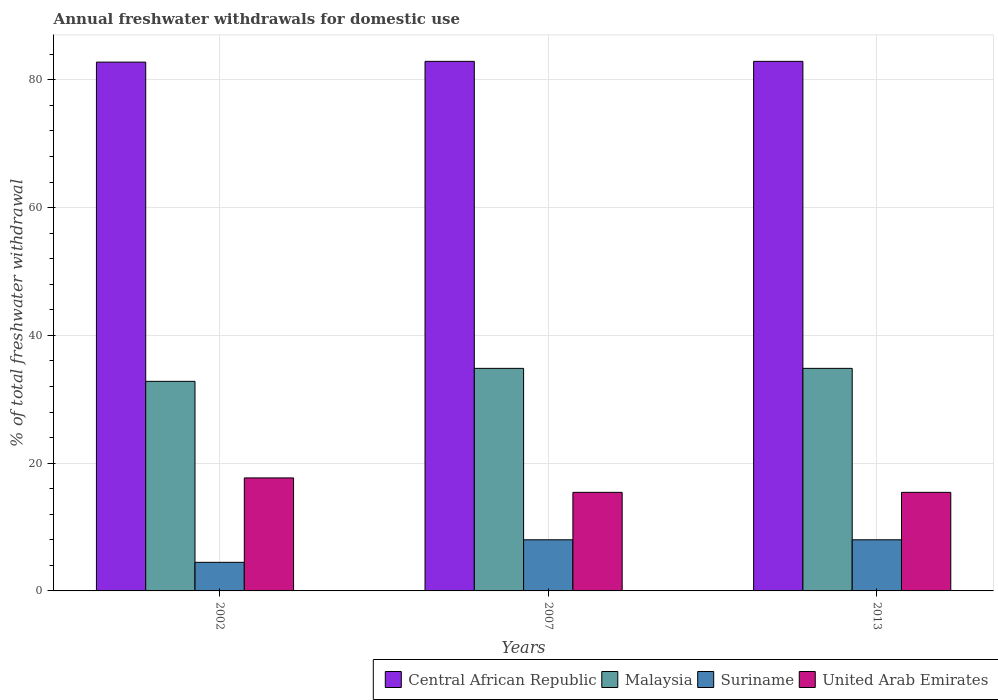How many different coloured bars are there?
Your answer should be compact. 4. In how many cases, is the number of bars for a given year not equal to the number of legend labels?
Your answer should be very brief. 0. What is the total annual withdrawals from freshwater in United Arab Emirates in 2007?
Make the answer very short. 15.43. Across all years, what is the maximum total annual withdrawals from freshwater in Malaysia?
Offer a terse response. 34.84. Across all years, what is the minimum total annual withdrawals from freshwater in United Arab Emirates?
Make the answer very short. 15.43. In which year was the total annual withdrawals from freshwater in United Arab Emirates minimum?
Ensure brevity in your answer.  2007. What is the total total annual withdrawals from freshwater in Central African Republic in the graph?
Give a very brief answer. 248.58. What is the difference between the total annual withdrawals from freshwater in United Arab Emirates in 2002 and that in 2013?
Provide a short and direct response. 2.26. What is the difference between the total annual withdrawals from freshwater in United Arab Emirates in 2002 and the total annual withdrawals from freshwater in Suriname in 2013?
Ensure brevity in your answer.  9.69. What is the average total annual withdrawals from freshwater in Suriname per year?
Your answer should be compact. 6.83. In the year 2002, what is the difference between the total annual withdrawals from freshwater in Suriname and total annual withdrawals from freshwater in Central African Republic?
Offer a very short reply. -78.3. What is the ratio of the total annual withdrawals from freshwater in United Arab Emirates in 2002 to that in 2007?
Make the answer very short. 1.15. Is the difference between the total annual withdrawals from freshwater in Suriname in 2007 and 2013 greater than the difference between the total annual withdrawals from freshwater in Central African Republic in 2007 and 2013?
Ensure brevity in your answer.  No. What is the difference between the highest and the second highest total annual withdrawals from freshwater in Central African Republic?
Give a very brief answer. 0. What is the difference between the highest and the lowest total annual withdrawals from freshwater in Central African Republic?
Your answer should be very brief. 0.12. Is the sum of the total annual withdrawals from freshwater in Central African Republic in 2002 and 2007 greater than the maximum total annual withdrawals from freshwater in Suriname across all years?
Provide a succinct answer. Yes. What does the 1st bar from the left in 2002 represents?
Provide a short and direct response. Central African Republic. What does the 4th bar from the right in 2007 represents?
Make the answer very short. Central African Republic. What is the difference between two consecutive major ticks on the Y-axis?
Keep it short and to the point. 20. Does the graph contain grids?
Offer a very short reply. Yes. How are the legend labels stacked?
Your answer should be compact. Horizontal. What is the title of the graph?
Keep it short and to the point. Annual freshwater withdrawals for domestic use. Does "United States" appear as one of the legend labels in the graph?
Ensure brevity in your answer.  No. What is the label or title of the Y-axis?
Make the answer very short. % of total freshwater withdrawal. What is the % of total freshwater withdrawal in Central African Republic in 2002?
Offer a terse response. 82.78. What is the % of total freshwater withdrawal in Malaysia in 2002?
Your answer should be compact. 32.81. What is the % of total freshwater withdrawal of Suriname in 2002?
Make the answer very short. 4.48. What is the % of total freshwater withdrawal in United Arab Emirates in 2002?
Provide a succinct answer. 17.69. What is the % of total freshwater withdrawal of Central African Republic in 2007?
Provide a short and direct response. 82.9. What is the % of total freshwater withdrawal in Malaysia in 2007?
Offer a terse response. 34.84. What is the % of total freshwater withdrawal in Suriname in 2007?
Keep it short and to the point. 8.01. What is the % of total freshwater withdrawal of United Arab Emirates in 2007?
Keep it short and to the point. 15.43. What is the % of total freshwater withdrawal in Central African Republic in 2013?
Your answer should be compact. 82.9. What is the % of total freshwater withdrawal of Malaysia in 2013?
Make the answer very short. 34.84. What is the % of total freshwater withdrawal in Suriname in 2013?
Provide a succinct answer. 8.01. What is the % of total freshwater withdrawal in United Arab Emirates in 2013?
Your answer should be very brief. 15.43. Across all years, what is the maximum % of total freshwater withdrawal of Central African Republic?
Give a very brief answer. 82.9. Across all years, what is the maximum % of total freshwater withdrawal of Malaysia?
Make the answer very short. 34.84. Across all years, what is the maximum % of total freshwater withdrawal in Suriname?
Your response must be concise. 8.01. Across all years, what is the maximum % of total freshwater withdrawal of United Arab Emirates?
Provide a short and direct response. 17.69. Across all years, what is the minimum % of total freshwater withdrawal of Central African Republic?
Keep it short and to the point. 82.78. Across all years, what is the minimum % of total freshwater withdrawal in Malaysia?
Offer a terse response. 32.81. Across all years, what is the minimum % of total freshwater withdrawal of Suriname?
Your answer should be compact. 4.48. Across all years, what is the minimum % of total freshwater withdrawal in United Arab Emirates?
Keep it short and to the point. 15.43. What is the total % of total freshwater withdrawal in Central African Republic in the graph?
Your answer should be compact. 248.58. What is the total % of total freshwater withdrawal of Malaysia in the graph?
Give a very brief answer. 102.49. What is the total % of total freshwater withdrawal in Suriname in the graph?
Your answer should be very brief. 20.49. What is the total % of total freshwater withdrawal in United Arab Emirates in the graph?
Make the answer very short. 48.55. What is the difference between the % of total freshwater withdrawal in Central African Republic in 2002 and that in 2007?
Offer a very short reply. -0.12. What is the difference between the % of total freshwater withdrawal in Malaysia in 2002 and that in 2007?
Offer a very short reply. -2.03. What is the difference between the % of total freshwater withdrawal in Suriname in 2002 and that in 2007?
Your answer should be very brief. -3.53. What is the difference between the % of total freshwater withdrawal of United Arab Emirates in 2002 and that in 2007?
Give a very brief answer. 2.26. What is the difference between the % of total freshwater withdrawal in Central African Republic in 2002 and that in 2013?
Offer a very short reply. -0.12. What is the difference between the % of total freshwater withdrawal in Malaysia in 2002 and that in 2013?
Your answer should be compact. -2.03. What is the difference between the % of total freshwater withdrawal in Suriname in 2002 and that in 2013?
Offer a terse response. -3.53. What is the difference between the % of total freshwater withdrawal of United Arab Emirates in 2002 and that in 2013?
Give a very brief answer. 2.26. What is the difference between the % of total freshwater withdrawal in Central African Republic in 2007 and that in 2013?
Ensure brevity in your answer.  0. What is the difference between the % of total freshwater withdrawal of Malaysia in 2007 and that in 2013?
Offer a very short reply. 0. What is the difference between the % of total freshwater withdrawal of Suriname in 2007 and that in 2013?
Your response must be concise. 0. What is the difference between the % of total freshwater withdrawal of Central African Republic in 2002 and the % of total freshwater withdrawal of Malaysia in 2007?
Provide a short and direct response. 47.94. What is the difference between the % of total freshwater withdrawal in Central African Republic in 2002 and the % of total freshwater withdrawal in Suriname in 2007?
Offer a terse response. 74.78. What is the difference between the % of total freshwater withdrawal in Central African Republic in 2002 and the % of total freshwater withdrawal in United Arab Emirates in 2007?
Ensure brevity in your answer.  67.35. What is the difference between the % of total freshwater withdrawal of Malaysia in 2002 and the % of total freshwater withdrawal of Suriname in 2007?
Your answer should be very brief. 24.8. What is the difference between the % of total freshwater withdrawal of Malaysia in 2002 and the % of total freshwater withdrawal of United Arab Emirates in 2007?
Provide a succinct answer. 17.38. What is the difference between the % of total freshwater withdrawal in Suriname in 2002 and the % of total freshwater withdrawal in United Arab Emirates in 2007?
Keep it short and to the point. -10.95. What is the difference between the % of total freshwater withdrawal in Central African Republic in 2002 and the % of total freshwater withdrawal in Malaysia in 2013?
Your answer should be very brief. 47.94. What is the difference between the % of total freshwater withdrawal of Central African Republic in 2002 and the % of total freshwater withdrawal of Suriname in 2013?
Ensure brevity in your answer.  74.78. What is the difference between the % of total freshwater withdrawal in Central African Republic in 2002 and the % of total freshwater withdrawal in United Arab Emirates in 2013?
Keep it short and to the point. 67.35. What is the difference between the % of total freshwater withdrawal in Malaysia in 2002 and the % of total freshwater withdrawal in Suriname in 2013?
Provide a succinct answer. 24.8. What is the difference between the % of total freshwater withdrawal in Malaysia in 2002 and the % of total freshwater withdrawal in United Arab Emirates in 2013?
Keep it short and to the point. 17.38. What is the difference between the % of total freshwater withdrawal in Suriname in 2002 and the % of total freshwater withdrawal in United Arab Emirates in 2013?
Your response must be concise. -10.95. What is the difference between the % of total freshwater withdrawal of Central African Republic in 2007 and the % of total freshwater withdrawal of Malaysia in 2013?
Your answer should be compact. 48.06. What is the difference between the % of total freshwater withdrawal in Central African Republic in 2007 and the % of total freshwater withdrawal in Suriname in 2013?
Offer a very short reply. 74.89. What is the difference between the % of total freshwater withdrawal of Central African Republic in 2007 and the % of total freshwater withdrawal of United Arab Emirates in 2013?
Ensure brevity in your answer.  67.47. What is the difference between the % of total freshwater withdrawal in Malaysia in 2007 and the % of total freshwater withdrawal in Suriname in 2013?
Give a very brief answer. 26.84. What is the difference between the % of total freshwater withdrawal in Malaysia in 2007 and the % of total freshwater withdrawal in United Arab Emirates in 2013?
Your answer should be compact. 19.41. What is the difference between the % of total freshwater withdrawal in Suriname in 2007 and the % of total freshwater withdrawal in United Arab Emirates in 2013?
Ensure brevity in your answer.  -7.42. What is the average % of total freshwater withdrawal in Central African Republic per year?
Provide a short and direct response. 82.86. What is the average % of total freshwater withdrawal of Malaysia per year?
Provide a succinct answer. 34.16. What is the average % of total freshwater withdrawal of Suriname per year?
Offer a terse response. 6.83. What is the average % of total freshwater withdrawal in United Arab Emirates per year?
Ensure brevity in your answer.  16.18. In the year 2002, what is the difference between the % of total freshwater withdrawal in Central African Republic and % of total freshwater withdrawal in Malaysia?
Ensure brevity in your answer.  49.97. In the year 2002, what is the difference between the % of total freshwater withdrawal in Central African Republic and % of total freshwater withdrawal in Suriname?
Give a very brief answer. 78.3. In the year 2002, what is the difference between the % of total freshwater withdrawal in Central African Republic and % of total freshwater withdrawal in United Arab Emirates?
Keep it short and to the point. 65.09. In the year 2002, what is the difference between the % of total freshwater withdrawal in Malaysia and % of total freshwater withdrawal in Suriname?
Your answer should be compact. 28.33. In the year 2002, what is the difference between the % of total freshwater withdrawal of Malaysia and % of total freshwater withdrawal of United Arab Emirates?
Provide a succinct answer. 15.12. In the year 2002, what is the difference between the % of total freshwater withdrawal of Suriname and % of total freshwater withdrawal of United Arab Emirates?
Offer a very short reply. -13.21. In the year 2007, what is the difference between the % of total freshwater withdrawal of Central African Republic and % of total freshwater withdrawal of Malaysia?
Ensure brevity in your answer.  48.06. In the year 2007, what is the difference between the % of total freshwater withdrawal in Central African Republic and % of total freshwater withdrawal in Suriname?
Provide a succinct answer. 74.89. In the year 2007, what is the difference between the % of total freshwater withdrawal in Central African Republic and % of total freshwater withdrawal in United Arab Emirates?
Your answer should be very brief. 67.47. In the year 2007, what is the difference between the % of total freshwater withdrawal in Malaysia and % of total freshwater withdrawal in Suriname?
Keep it short and to the point. 26.84. In the year 2007, what is the difference between the % of total freshwater withdrawal of Malaysia and % of total freshwater withdrawal of United Arab Emirates?
Your response must be concise. 19.41. In the year 2007, what is the difference between the % of total freshwater withdrawal in Suriname and % of total freshwater withdrawal in United Arab Emirates?
Make the answer very short. -7.42. In the year 2013, what is the difference between the % of total freshwater withdrawal of Central African Republic and % of total freshwater withdrawal of Malaysia?
Offer a terse response. 48.06. In the year 2013, what is the difference between the % of total freshwater withdrawal of Central African Republic and % of total freshwater withdrawal of Suriname?
Your answer should be very brief. 74.89. In the year 2013, what is the difference between the % of total freshwater withdrawal of Central African Republic and % of total freshwater withdrawal of United Arab Emirates?
Your answer should be compact. 67.47. In the year 2013, what is the difference between the % of total freshwater withdrawal of Malaysia and % of total freshwater withdrawal of Suriname?
Give a very brief answer. 26.84. In the year 2013, what is the difference between the % of total freshwater withdrawal of Malaysia and % of total freshwater withdrawal of United Arab Emirates?
Make the answer very short. 19.41. In the year 2013, what is the difference between the % of total freshwater withdrawal of Suriname and % of total freshwater withdrawal of United Arab Emirates?
Your answer should be very brief. -7.42. What is the ratio of the % of total freshwater withdrawal in Malaysia in 2002 to that in 2007?
Ensure brevity in your answer.  0.94. What is the ratio of the % of total freshwater withdrawal in Suriname in 2002 to that in 2007?
Your response must be concise. 0.56. What is the ratio of the % of total freshwater withdrawal of United Arab Emirates in 2002 to that in 2007?
Your response must be concise. 1.15. What is the ratio of the % of total freshwater withdrawal in Central African Republic in 2002 to that in 2013?
Provide a short and direct response. 1. What is the ratio of the % of total freshwater withdrawal in Malaysia in 2002 to that in 2013?
Your response must be concise. 0.94. What is the ratio of the % of total freshwater withdrawal of Suriname in 2002 to that in 2013?
Your answer should be very brief. 0.56. What is the ratio of the % of total freshwater withdrawal in United Arab Emirates in 2002 to that in 2013?
Offer a very short reply. 1.15. What is the ratio of the % of total freshwater withdrawal of Central African Republic in 2007 to that in 2013?
Your answer should be very brief. 1. What is the ratio of the % of total freshwater withdrawal in Malaysia in 2007 to that in 2013?
Your answer should be compact. 1. What is the ratio of the % of total freshwater withdrawal of United Arab Emirates in 2007 to that in 2013?
Your response must be concise. 1. What is the difference between the highest and the second highest % of total freshwater withdrawal of Central African Republic?
Your answer should be compact. 0. What is the difference between the highest and the second highest % of total freshwater withdrawal of Suriname?
Give a very brief answer. 0. What is the difference between the highest and the second highest % of total freshwater withdrawal of United Arab Emirates?
Your answer should be compact. 2.26. What is the difference between the highest and the lowest % of total freshwater withdrawal in Central African Republic?
Offer a terse response. 0.12. What is the difference between the highest and the lowest % of total freshwater withdrawal of Malaysia?
Your answer should be compact. 2.03. What is the difference between the highest and the lowest % of total freshwater withdrawal in Suriname?
Provide a succinct answer. 3.53. What is the difference between the highest and the lowest % of total freshwater withdrawal of United Arab Emirates?
Your answer should be compact. 2.26. 